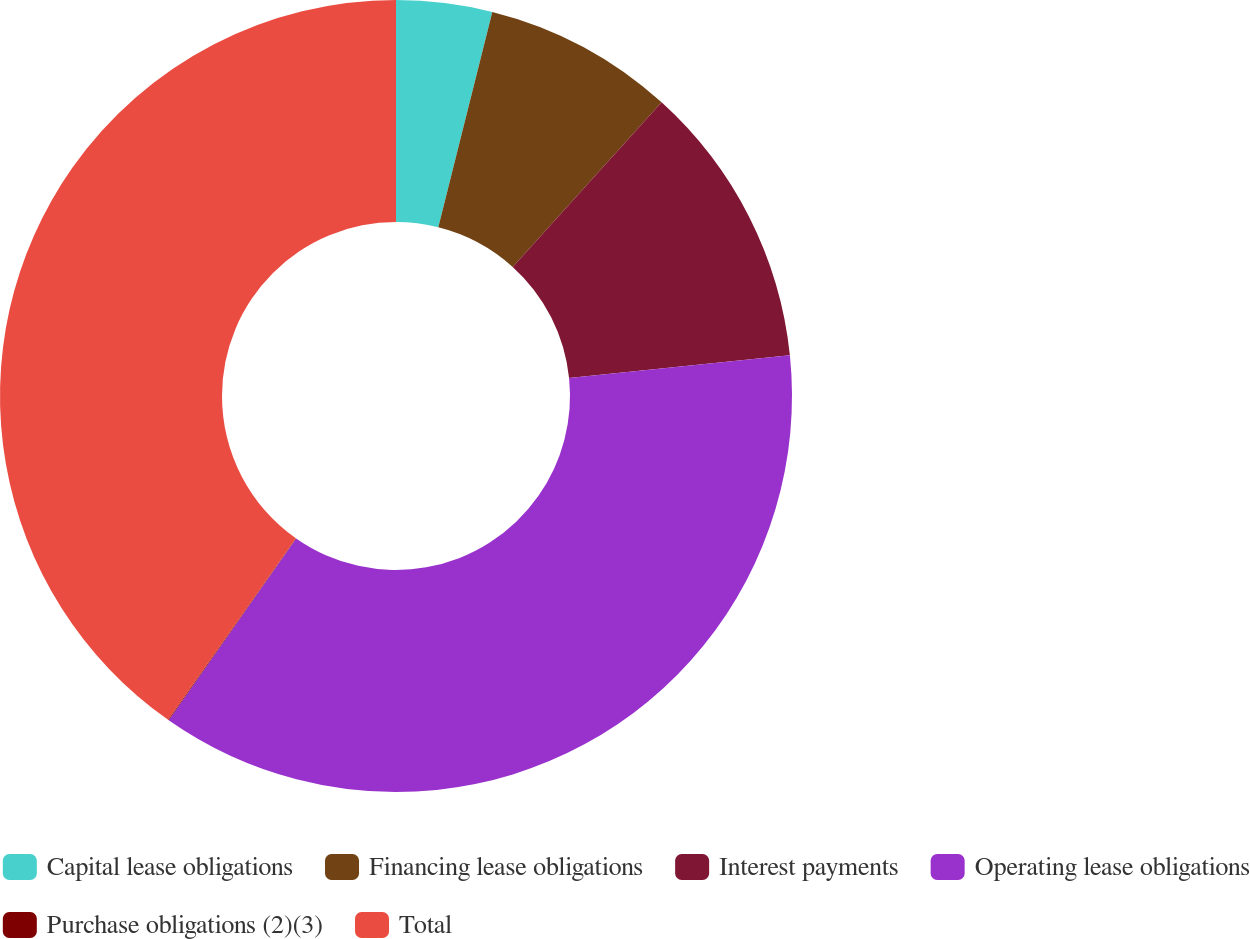<chart> <loc_0><loc_0><loc_500><loc_500><pie_chart><fcel>Capital lease obligations<fcel>Financing lease obligations<fcel>Interest payments<fcel>Operating lease obligations<fcel>Purchase obligations (2)(3)<fcel>Total<nl><fcel>3.91%<fcel>7.79%<fcel>11.66%<fcel>36.37%<fcel>0.03%<fcel>40.24%<nl></chart> 